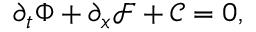<formula> <loc_0><loc_0><loc_500><loc_500>\partial _ { t } \Phi + \partial _ { x } \mathcal { F } + \mathcal { C } = 0 ,</formula> 